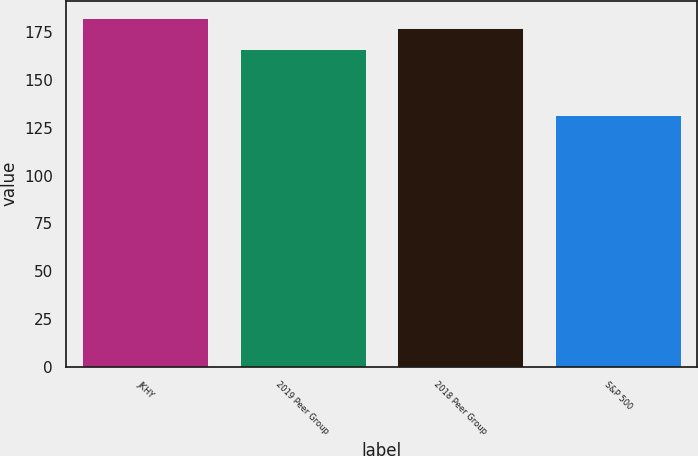<chart> <loc_0><loc_0><loc_500><loc_500><bar_chart><fcel>JKHY<fcel>2019 Peer Group<fcel>2018 Peer Group<fcel>S&P 500<nl><fcel>182.31<fcel>166.15<fcel>177.26<fcel>131.7<nl></chart> 